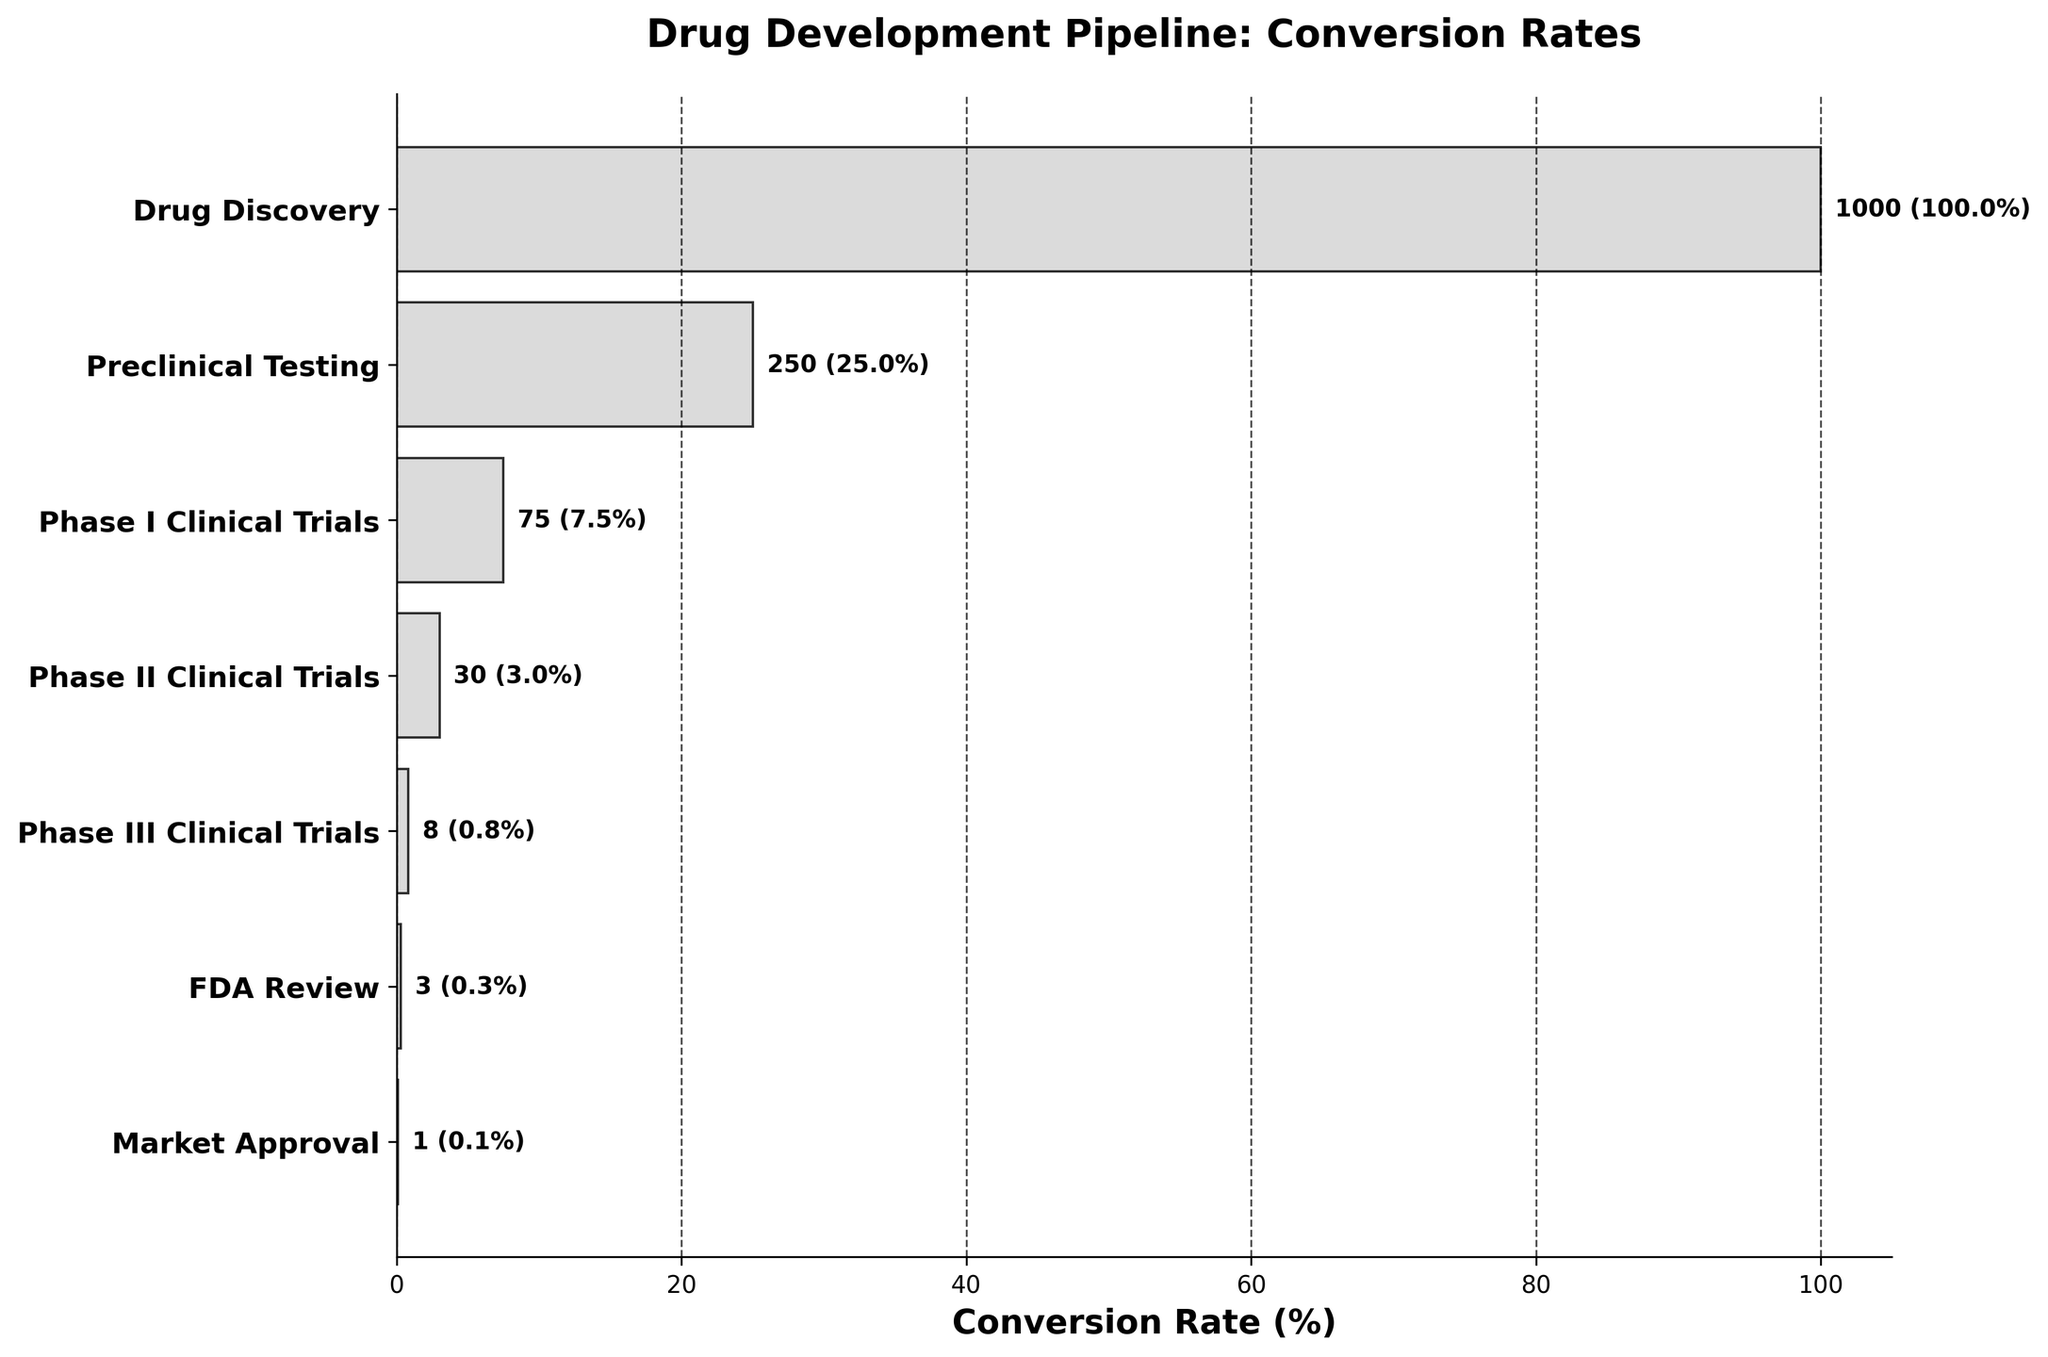What is the title of the chart? The title of the chart is located at the top and usually describes the topic of the chart. In this case, it reads "Drug Development Pipeline: Conversion Rates".
Answer: Drug Development Pipeline: Conversion Rates What is the highest conversion rate stage in the funnel? The bar representing Drug Discovery is the widest and has a conversion rate of 100%. Hence, Drug Discovery is the stage with the highest conversion rate.
Answer: Drug Discovery How many candidates make it to the Market Approval stage? The label next to the bar for the Market Approval stage shows "1 (0.1%)", indicating that only 1 candidate makes it to the Market Approval stage.
Answer: 1 What is the conversion rate for Phase III Clinical Trials compared to Phase II? The conversion rate for Phase III Clinical Trials is indicated next to its bar as 0.8%, and for Phase II Clinical Trials, it is 3%. Comparing the two, 0.8% is less than 3%.
Answer: Less than How many stages are represented in the funnel? The funnel contains stages listed on the y-axis. Counting the distinct labels, there are seven stages represented.
Answer: 7 Which stage has the largest drop in the number of candidates from the previous stage? The conversion rate decrease is the steepest from Drug Discovery (1000 candidates) to Preclinical Testing (250 candidates), which is a fall of 750 candidates.
Answer: From Drug Discovery to Preclinical Testing What proportion of the initial candidates reach Phase I Clinical Trials? The label for Phase I Clinical Trials shows 75 candidates, out of an initial 1000 candidates in Drug Discovery. The proportion is calculated as 75/1000, which is 7.5%.
Answer: 7.5% What is the difference in conversion rates between Preclinical Testing and FDA Review stages? Conversion rates are given as 25% for Preclinical Testing and 0.3% for FDA Review. The difference is calculated as 25 - 0.3 = 24.7%.
Answer: 24.7% Which stage reflects less than 1% conversion rate first, and what is its exact rate? The first stage with a conversion rate less than 1% is Phase III Clinical Trials, with an exact rate of 0.8%.
Answer: Phase III Clinical Trials; 0.8% How does the conversion for Market Approval compare with the initial Drug Discovery stage? Market Approval has 1 candidate out of an initial 1000 in Drug Discovery, which translates to 0.1% compared to the 100% in Drug Discovery, indicating a significant decrease.
Answer: Significantly lower 